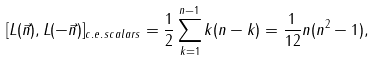Convert formula to latex. <formula><loc_0><loc_0><loc_500><loc_500>[ L ( \vec { n } ) , L ( - \vec { n } ) ] _ { c . e . \, s c a l a r s } = \frac { 1 } { 2 } \sum _ { k = 1 } ^ { n - 1 } k ( n - k ) = \frac { 1 } { 1 2 } n ( n ^ { 2 } - 1 ) ,</formula> 